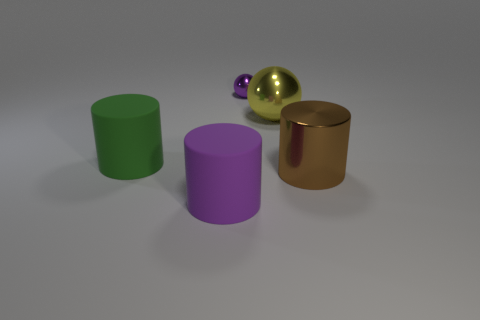Is there anything else that is the same size as the purple ball?
Make the answer very short. No. What number of other shiny things have the same shape as the big green object?
Your response must be concise. 1. There is a metal ball that is the same size as the brown metal cylinder; what color is it?
Keep it short and to the point. Yellow. Is there a large blue rubber cylinder?
Give a very brief answer. No. What is the shape of the purple object to the left of the tiny sphere?
Give a very brief answer. Cylinder. What number of rubber cylinders are behind the big purple matte cylinder and in front of the big brown metallic cylinder?
Make the answer very short. 0. Are there any balls made of the same material as the big green object?
Ensure brevity in your answer.  No. What size is the object that is the same color as the small metallic sphere?
Provide a short and direct response. Large. How many cylinders are large metallic objects or large green rubber things?
Make the answer very short. 2. How big is the purple matte object?
Make the answer very short. Large. 